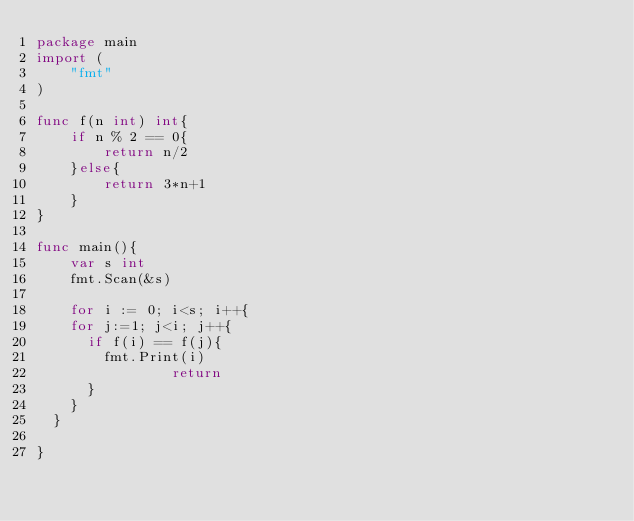Convert code to text. <code><loc_0><loc_0><loc_500><loc_500><_Go_>package main
import (
	"fmt"
)

func f(n int) int{
	if n % 2 == 0{
		return n/2
	}else{
		return 3*n+1
	}
}

func main(){
	var s int
	fmt.Scan(&s)

	for i := 0; i<s; i++{
    for j:=1; j<i; j++{
      if f(i) == f(j){
        fmt.Print(i)
				return
      }
    }
  }

}

</code> 